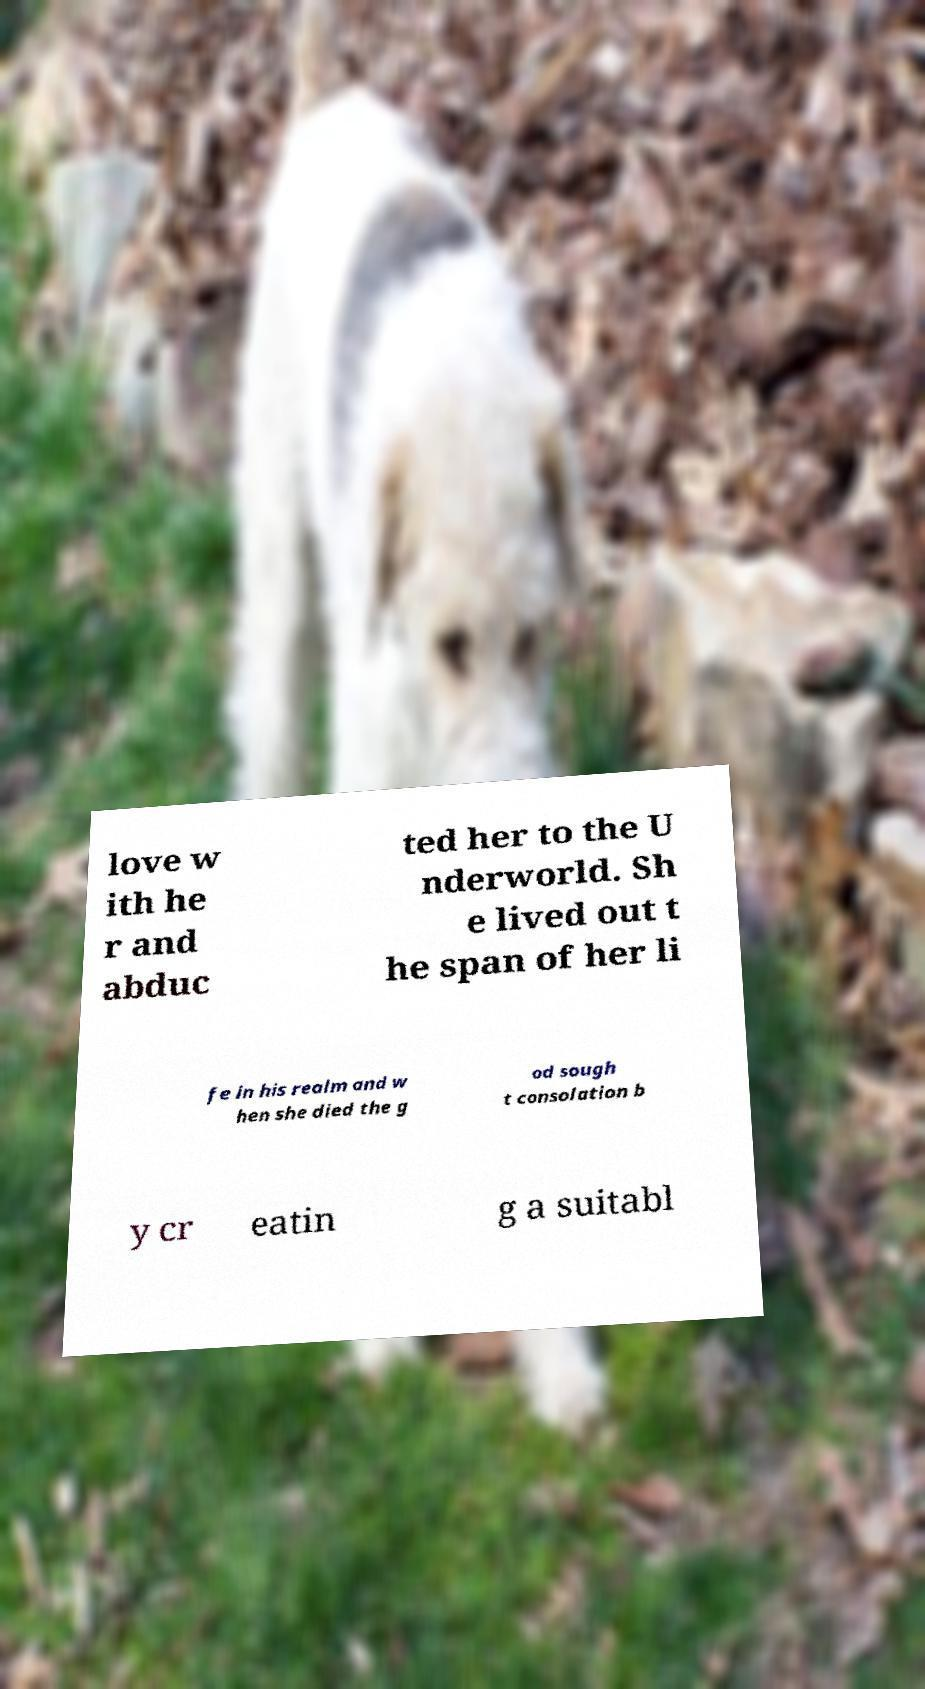For documentation purposes, I need the text within this image transcribed. Could you provide that? love w ith he r and abduc ted her to the U nderworld. Sh e lived out t he span of her li fe in his realm and w hen she died the g od sough t consolation b y cr eatin g a suitabl 